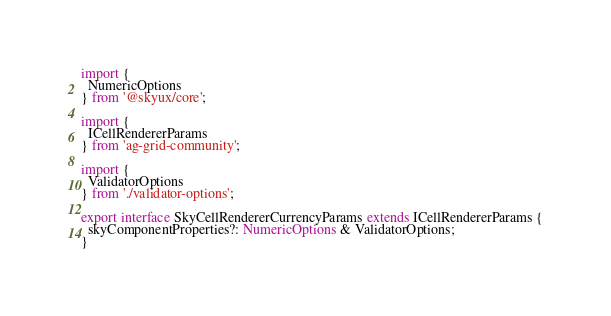Convert code to text. <code><loc_0><loc_0><loc_500><loc_500><_TypeScript_>import {
  NumericOptions
} from '@skyux/core';

import {
  ICellRendererParams
} from 'ag-grid-community';

import {
  ValidatorOptions
} from './validator-options';

export interface SkyCellRendererCurrencyParams extends ICellRendererParams {
  skyComponentProperties?: NumericOptions & ValidatorOptions;
}
</code> 